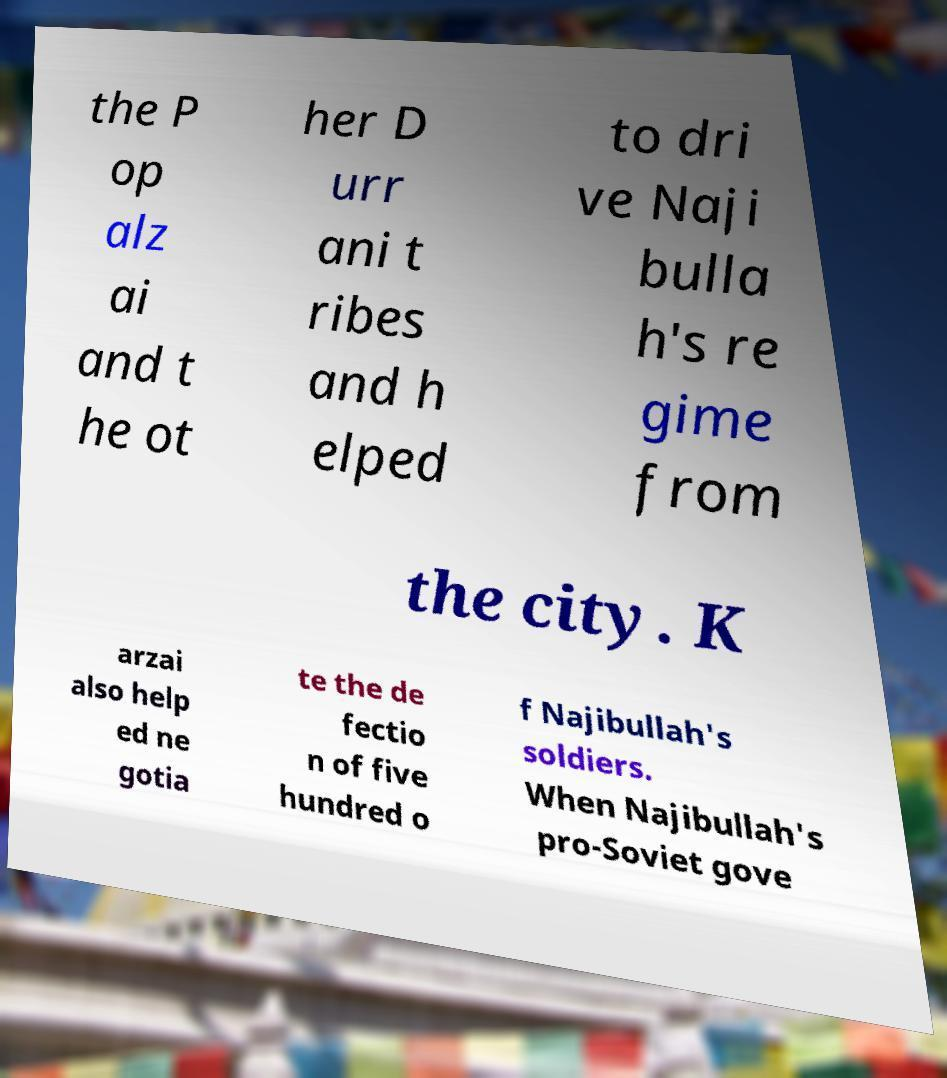Could you extract and type out the text from this image? the P op alz ai and t he ot her D urr ani t ribes and h elped to dri ve Naji bulla h's re gime from the city. K arzai also help ed ne gotia te the de fectio n of five hundred o f Najibullah's soldiers. When Najibullah's pro-Soviet gove 